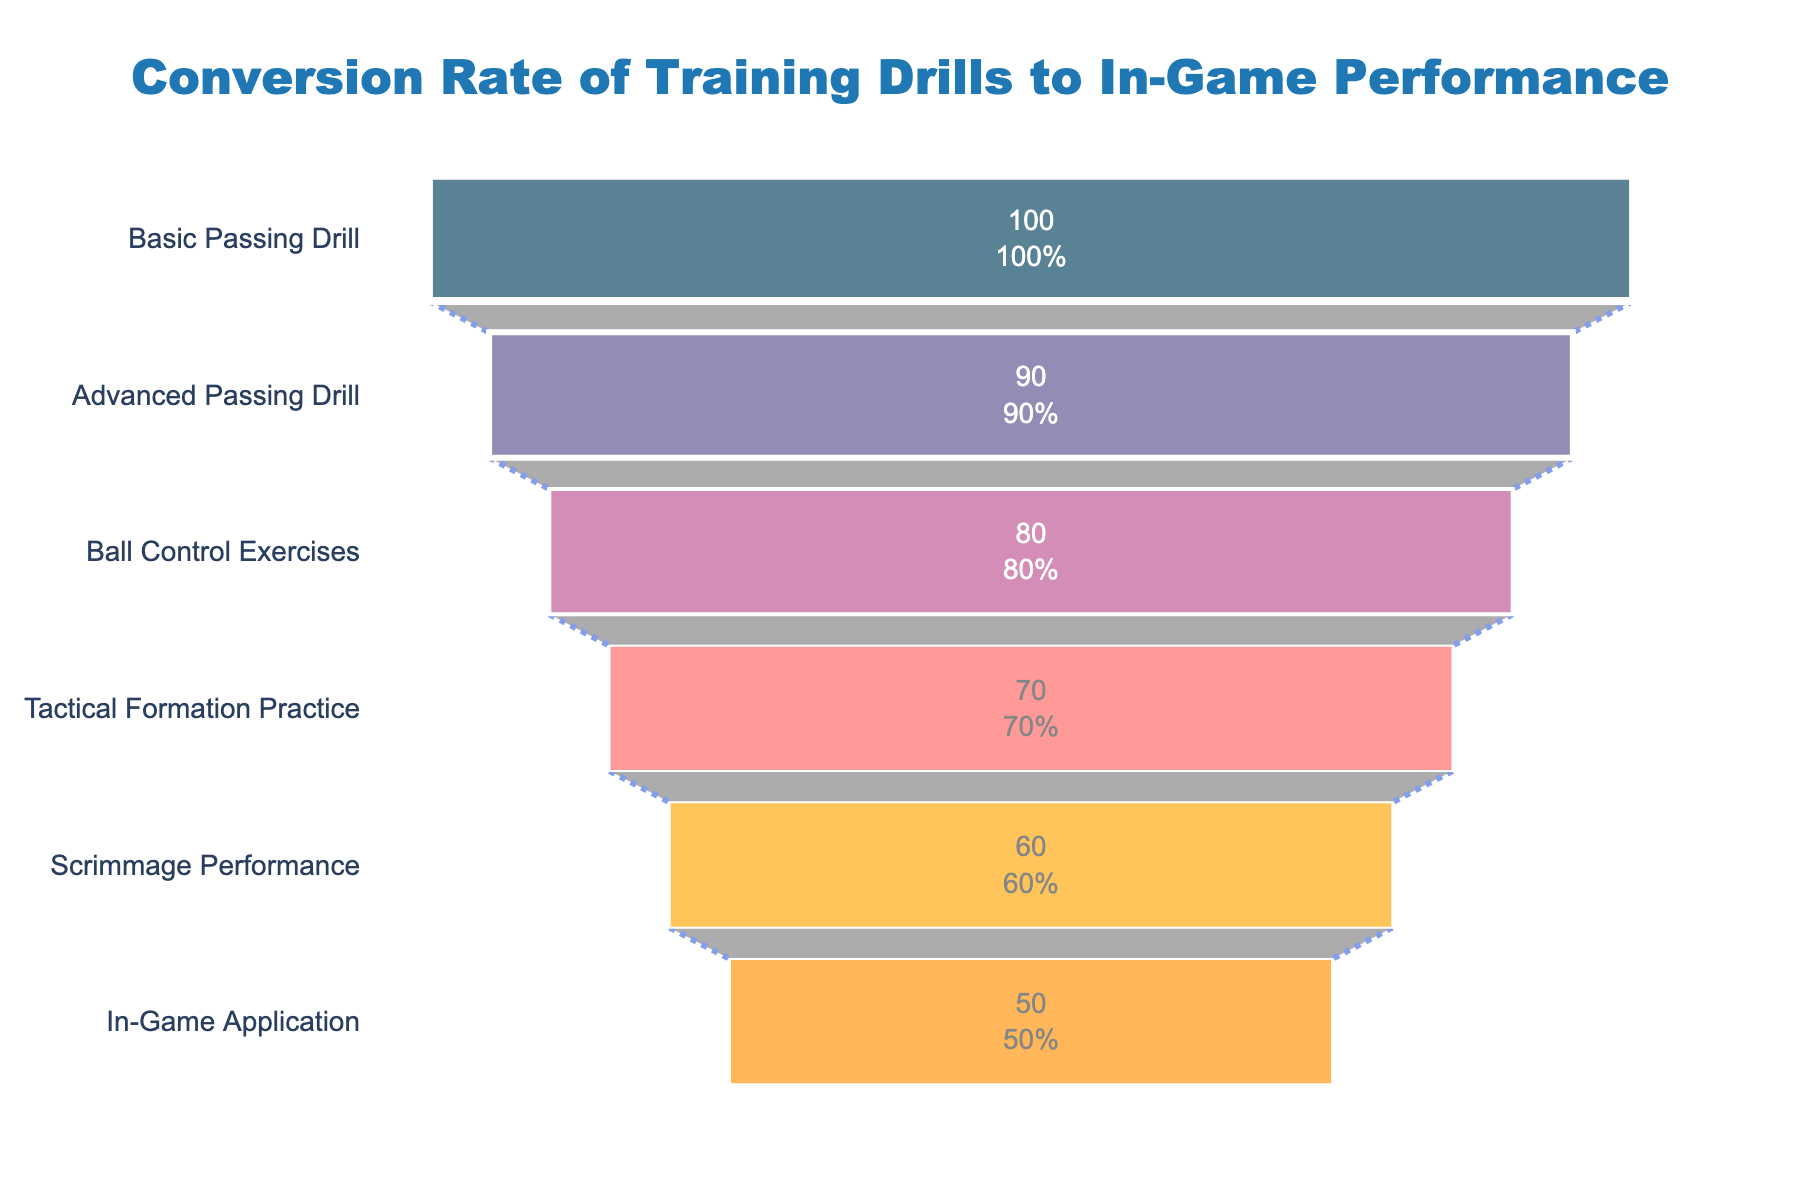What is the title of the funnel chart? The title is located at the top of the chart and provides a summary of what the chart represents. It reads "Conversion Rate of Training Drills to In-Game Performance."
Answer: Conversion Rate of Training Drills to In-Game Performance How many stages are shown in the funnel chart? Count the distinct stages listed on the y-axis of the funnel chart. There are six stages ranging from "Basic Passing Drill" to "In-Game Application".
Answer: 6 Which training drill shows the lowest conversion rate? Look at each stage's conversion rate from the chart. The lowest conversion rate is at the "In-Game Application" stage, which shows a 50% conversion rate.
Answer: In-Game Application What is the conversion rate for the Advanced Passing Drill stage? Locate the "Advanced Passing Drill" stage on the chart and note its associated conversion rate. The rate for this stage is displayed as 90%.
Answer: 90% What color is used to represent the Scrimmage Performance stage? Identify the color used in the visual representation of the "Scrimmage Performance" stage within the funnel. It is an orange-yellow color.
Answer: Orange-yellow How does the number of players change from the Basic Passing Drill to the Ball Control Exercises stage? Subtract the number of players in the Ball Control Exercises stage from the Basic Passing Drill stage. 50 players at the beginning reduced to 40 players at this stage shows a decrease by 10 players.
Answer: Decreases by 10 What is the average conversion rate from the Ball Control Exercises stage to the Scrimmage Performance stage? Identify the conversion rates for the stages from Ball Control Exercises to Scrimmage Performance. The rates are 80%, 70%, and 60%. Add these rates together and divide by the number of stages (3) to find the average ((80 + 70 + 60) / 3 = 70%).
Answer: 70% Compare the players' number from the Tactical Formation Practice stage to the In-Game Application stage. Compare the number of players at the "Tactical Formation Practice" (35 players) against the "In-Game Application" (25 players). The difference is 35 - 25 = 10 players.
Answer: 10 players more in Tactical Formation Practice If the Scrimmage Performance stage had a 65% conversion rate instead of 60%, what would the conversion rate to In-Game Application be? With a hypothetical 65% conversion rate at Scrimmage Performance, calculate the subsequent conversion. From the data, the next stage decreases by 10 players, maintaining the same rate (25/30 = 50%). Thus, the final rate to In-Game Application would remain at 50%.
Answer: 50% What is the purpose of the annotation at the bottom of the chart? The annotation provides motivational text to encourage the viewer. It states, "Keep pushing, team! Every drill counts!", which is aimed to motivate the players by underscoring the importance of each drill.
Answer: Motivational encouragement 